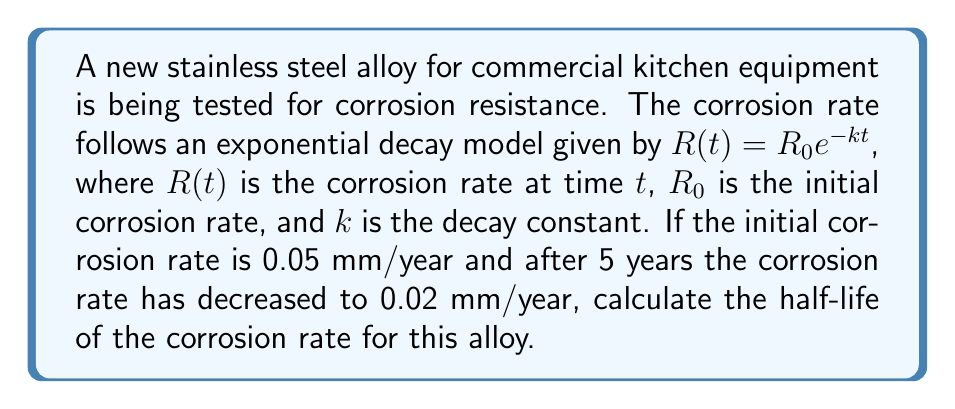Give your solution to this math problem. To solve this problem, we'll follow these steps:

1) We're given the exponential decay model: $R(t) = R_0e^{-kt}$

2) We know:
   $R_0 = 0.05$ mm/year
   $R(5) = 0.02$ mm/year
   $t = 5$ years

3) Let's substitute these values into the equation:
   $0.02 = 0.05e^{-5k}$

4) Divide both sides by 0.05:
   $\frac{0.02}{0.05} = e^{-5k}$
   $0.4 = e^{-5k}$

5) Take the natural log of both sides:
   $\ln(0.4) = -5k$

6) Solve for $k$:
   $k = -\frac{\ln(0.4)}{5} \approx 0.1833$

7) Now that we have $k$, we can find the half-life. The half-life is the time it takes for the quantity to decrease to half its initial value. Let's call this time $t_{1/2}$:

   $\frac{R_0}{2} = R_0e^{-kt_{1/2}}$

8) The $R_0$ cancels out:
   $\frac{1}{2} = e^{-kt_{1/2}}$

9) Take the natural log of both sides:
   $\ln(\frac{1}{2}) = -kt_{1/2}$

10) Solve for $t_{1/2}$:
    $t_{1/2} = -\frac{\ln(\frac{1}{2})}{k} = \frac{\ln(2)}{k}$

11) Substitute the value of $k$ we found earlier:
    $t_{1/2} = \frac{\ln(2)}{0.1833} \approx 3.78$ years

Therefore, the half-life of the corrosion rate for this alloy is approximately 3.78 years.
Answer: 3.78 years 